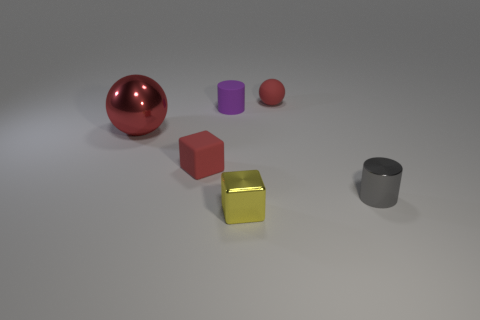There is a cube in front of the cylinder in front of the red metallic sphere; how many red blocks are on the right side of it?
Ensure brevity in your answer.  0. There is another red object that is the same shape as the red shiny object; what is its size?
Provide a short and direct response. Small. Is there anything else that has the same size as the purple thing?
Offer a terse response. Yes. Are the small object in front of the metal cylinder and the small purple cylinder made of the same material?
Provide a short and direct response. No. The other matte thing that is the same shape as the yellow object is what color?
Ensure brevity in your answer.  Red. How many other things are the same color as the small matte ball?
Provide a short and direct response. 2. Is the shape of the purple rubber object left of the gray metallic cylinder the same as the tiny thing that is in front of the gray object?
Ensure brevity in your answer.  No. What number of blocks are either small gray things or small yellow rubber things?
Your answer should be very brief. 0. Are there fewer small yellow things that are on the left side of the small rubber cylinder than cyan cylinders?
Your response must be concise. No. How many other things are there of the same material as the red cube?
Provide a succinct answer. 2. 